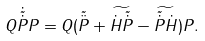<formula> <loc_0><loc_0><loc_500><loc_500>Q \dot { \tilde { \dot { P } } } P = Q ( \tilde { \ddot { P } } + \widetilde { \dot { H } \tilde { \dot { P } } } - \widetilde { \tilde { \dot { P } } \dot { H } } ) P .</formula> 